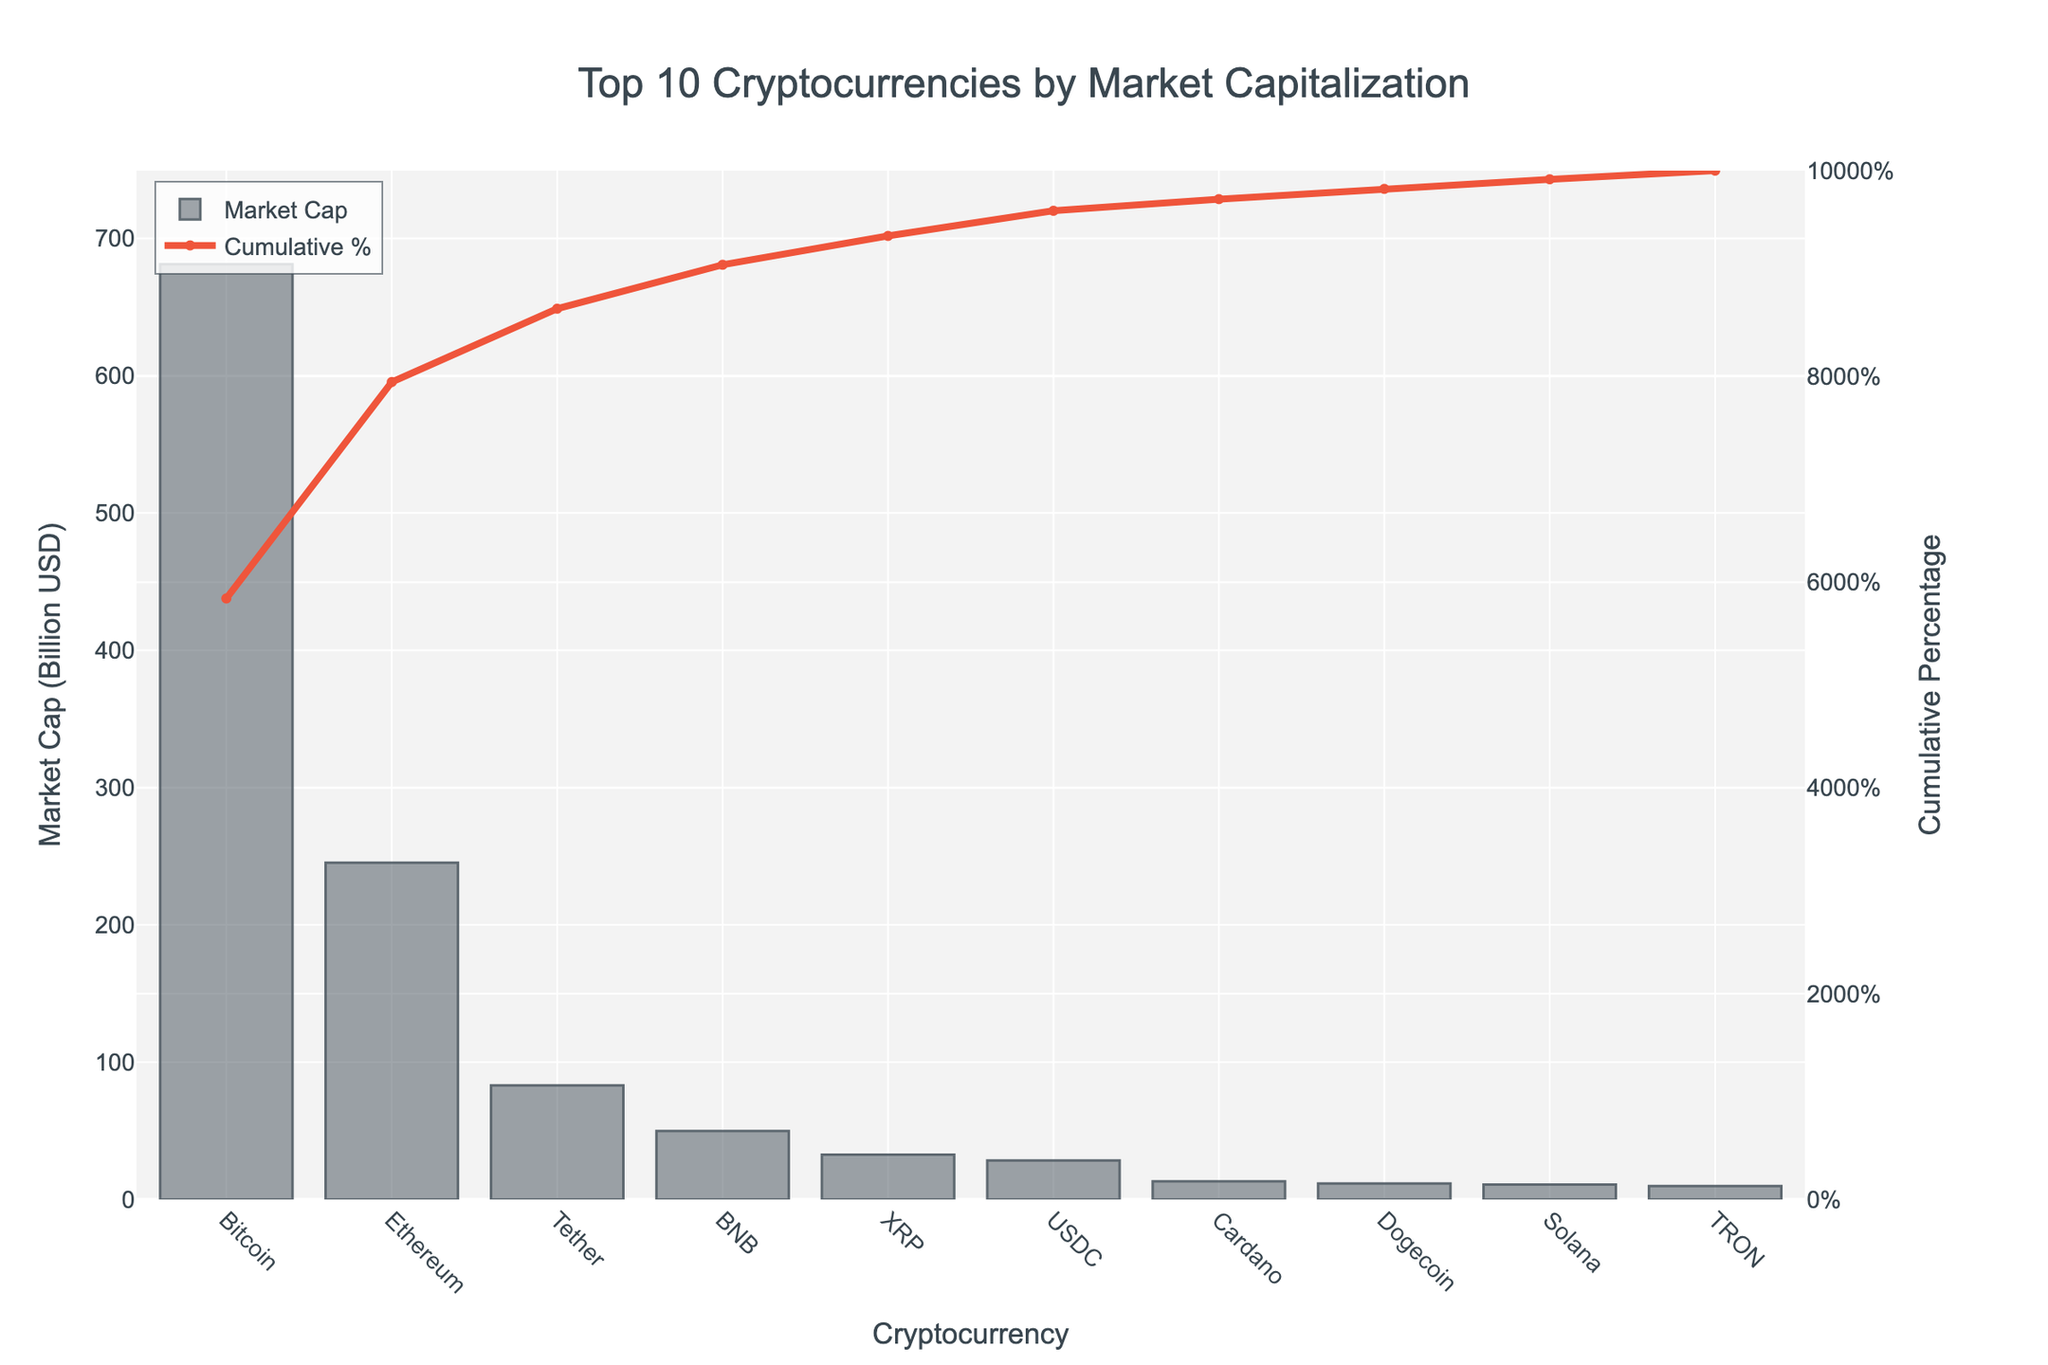What's the market capitalization of Ethereum? Locate Ethereum on the x-axis and check its corresponding bar height on the y-axis. The label on the bar shows its market capitalization, which is around 245.3 billion USD.
Answer: 245.3 billion USD Which cryptocurrency has the lowest market cap in the top 10? Locate the shortest bar in the graph and check the corresponding x-axis label for the cryptocurrency name. The lowest bar represents TRON with a market cap of around 9.8 billion USD.
Answer: TRON What's the difference in market capitalization between Bitcoin and BNB? Locate the bars for Bitcoin and BNB on the x-axis and note their y-axis values. Subtract the market cap of BNB (49.8 billion USD) from Bitcoin's market cap (681.2 billion USD).
Answer: 631.4 billion USD What is the cumulative market cap percentage after including Dogecoin? Find Dogecoin on the x-axis, then look at the corresponding point on the line for cumulative percentage on the secondary y-axis for the value.
Answer: Approximately 97.2% How many cryptocurrencies have a market cap exceeding 50 billion USD? Count the bars that extend above the 50 billion USD mark on the y-axis. Bitcoin, Ethereum, and Tether have market caps exceeding this value.
Answer: 3 Which coin has a higher market cap: Cardano or Solana? Locate the bars for Cardano and Solana on the x-axis and compare their heights to see which is taller. Cardano has a higher market cap.
Answer: Cardano What's the cumulative market cap percentage for the top three cryptocurrencies? Identify the top three cryptocurrencies (Bitcoin, Ethereum, and Tether) and their cumulative percentage on the secondary y-axis after Tether. It's approximately 75.2%.
Answer: Approximately 75.2% What is the average market cap of the cryptocurrencies in the chart? Sum the market caps of all the cryptocurrencies and divide by the number of cryptocurrencies (10). The total is (681.2 + 245.3 + 83.1 + 49.8 + 32.7 + 28.5 + 13.2 + 11.6 + 10.9 + 9.8) billion USD, and the average is the sum divided by 10.
Answer: Approximately 116.6 billion USD What is the market cap difference between the fourth and fifth largest cryptocurrencies? Locate the fourth (BNB) and fifth (XRP) cryptocurrencies on the x-axis, then subtract the market cap of XRP (32.7 billion USD) from BNB (49.8 billion USD).
Answer: 17.1 billion USD 